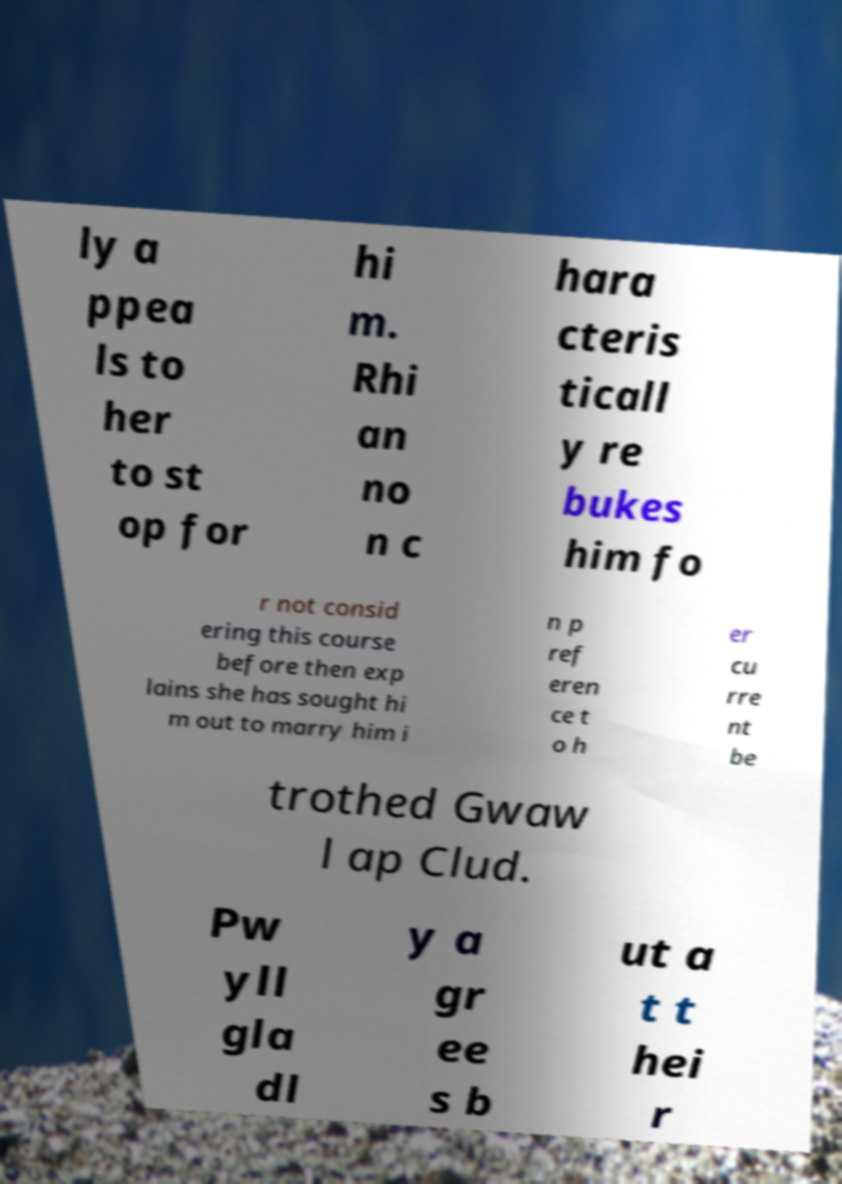I need the written content from this picture converted into text. Can you do that? ly a ppea ls to her to st op for hi m. Rhi an no n c hara cteris ticall y re bukes him fo r not consid ering this course before then exp lains she has sought hi m out to marry him i n p ref eren ce t o h er cu rre nt be trothed Gwaw l ap Clud. Pw yll gla dl y a gr ee s b ut a t t hei r 